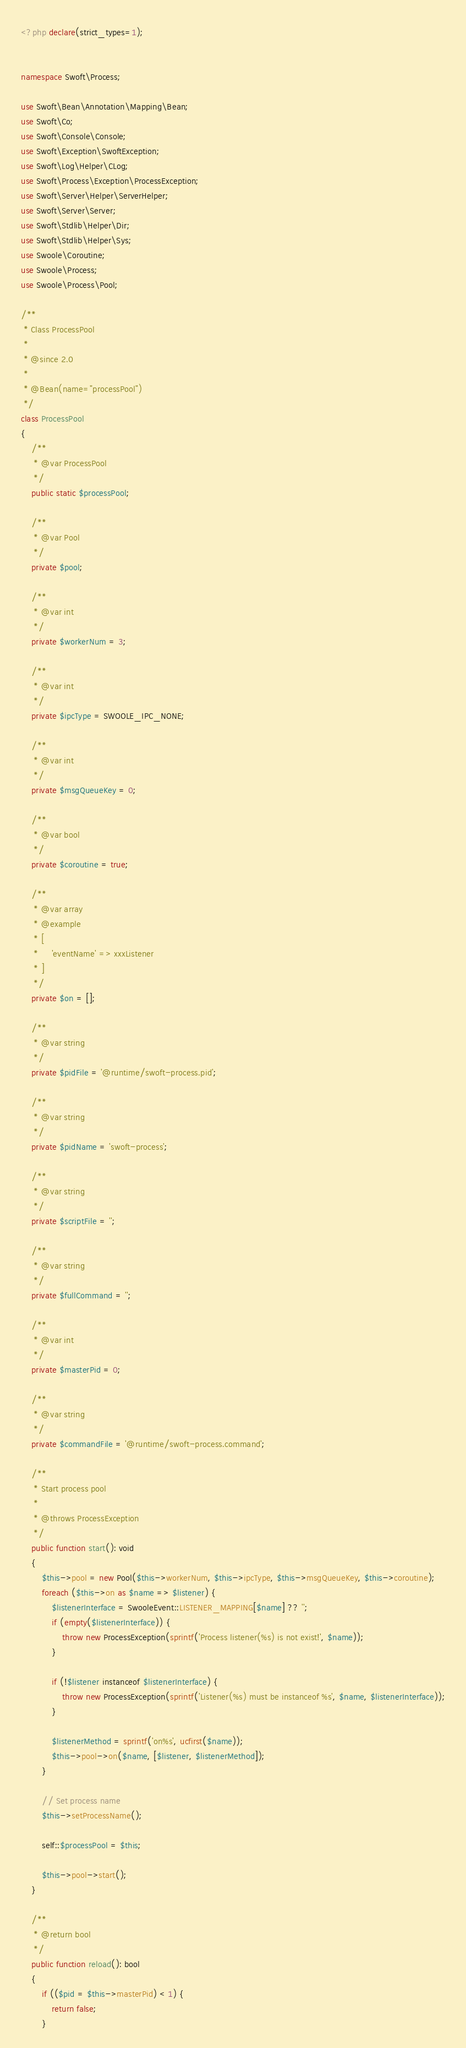Convert code to text. <code><loc_0><loc_0><loc_500><loc_500><_PHP_><?php declare(strict_types=1);


namespace Swoft\Process;

use Swoft\Bean\Annotation\Mapping\Bean;
use Swoft\Co;
use Swoft\Console\Console;
use Swoft\Exception\SwoftException;
use Swoft\Log\Helper\CLog;
use Swoft\Process\Exception\ProcessException;
use Swoft\Server\Helper\ServerHelper;
use Swoft\Server\Server;
use Swoft\Stdlib\Helper\Dir;
use Swoft\Stdlib\Helper\Sys;
use Swoole\Coroutine;
use Swoole\Process;
use Swoole\Process\Pool;

/**
 * Class ProcessPool
 *
 * @since 2.0
 *
 * @Bean(name="processPool")
 */
class ProcessPool
{
    /**
     * @var ProcessPool
     */
    public static $processPool;

    /**
     * @var Pool
     */
    private $pool;

    /**
     * @var int
     */
    private $workerNum = 3;

    /**
     * @var int
     */
    private $ipcType = SWOOLE_IPC_NONE;

    /**
     * @var int
     */
    private $msgQueueKey = 0;

    /**
     * @var bool
     */
    private $coroutine = true;

    /**
     * @var array
     * @example
     * [
     *     'eventName' => xxxListener
     * ]
     */
    private $on = [];

    /**
     * @var string
     */
    private $pidFile = '@runtime/swoft-process.pid';

    /**
     * @var string
     */
    private $pidName = 'swoft-process';

    /**
     * @var string
     */
    private $scriptFile = '';

    /**
     * @var string
     */
    private $fullCommand = '';

    /**
     * @var int
     */
    private $masterPid = 0;

    /**
     * @var string
     */
    private $commandFile = '@runtime/swoft-process.command';

    /**
     * Start process pool
     *
     * @throws ProcessException
     */
    public function start(): void
    {
        $this->pool = new Pool($this->workerNum, $this->ipcType, $this->msgQueueKey, $this->coroutine);
        foreach ($this->on as $name => $listener) {
            $listenerInterface = SwooleEvent::LISTENER_MAPPING[$name] ?? '';
            if (empty($listenerInterface)) {
                throw new ProcessException(sprintf('Process listener(%s) is not exist!', $name));
            }

            if (!$listener instanceof $listenerInterface) {
                throw new ProcessException(sprintf('Listener(%s) must be instanceof %s', $name, $listenerInterface));
            }

            $listenerMethod = sprintf('on%s', ucfirst($name));
            $this->pool->on($name, [$listener, $listenerMethod]);
        }

        // Set process name
        $this->setProcessName();

        self::$processPool = $this;

        $this->pool->start();
    }

    /**
     * @return bool
     */
    public function reload(): bool
    {
        if (($pid = $this->masterPid) < 1) {
            return false;
        }
</code> 